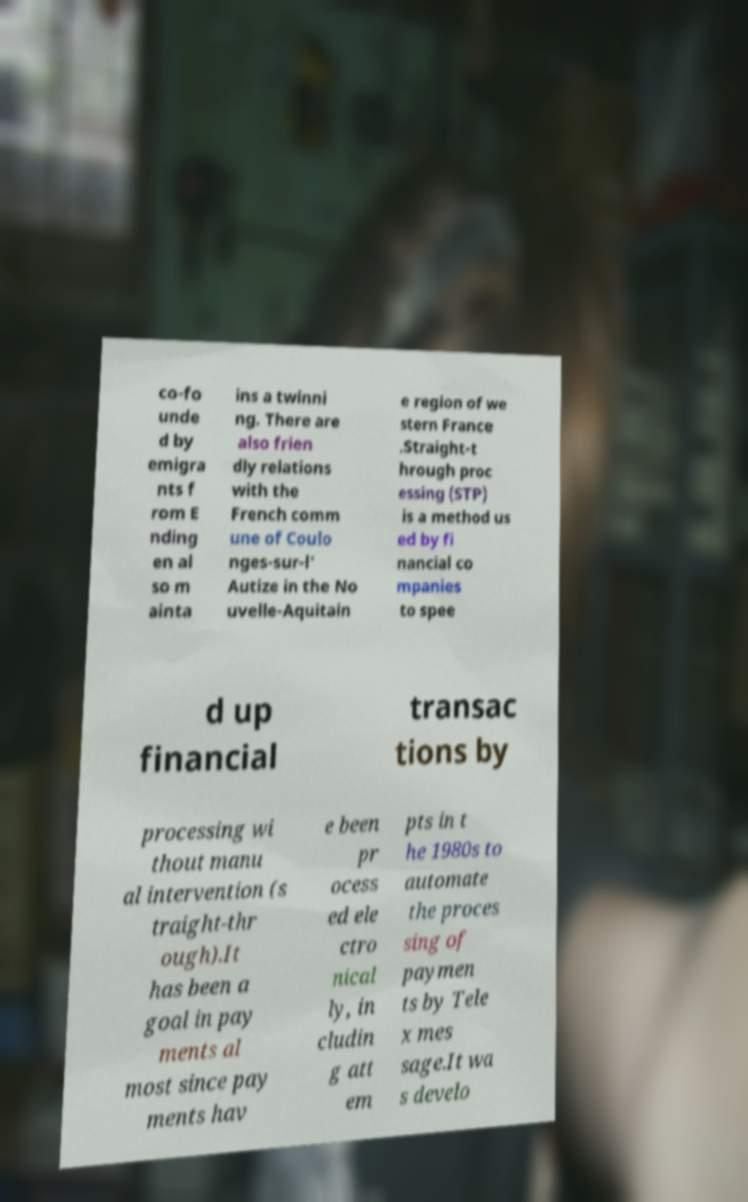I need the written content from this picture converted into text. Can you do that? co-fo unde d by emigra nts f rom E nding en al so m ainta ins a twinni ng. There are also frien dly relations with the French comm une of Coulo nges-sur-l' Autize in the No uvelle-Aquitain e region of we stern France .Straight-t hrough proc essing (STP) is a method us ed by fi nancial co mpanies to spee d up financial transac tions by processing wi thout manu al intervention (s traight-thr ough).It has been a goal in pay ments al most since pay ments hav e been pr ocess ed ele ctro nical ly, in cludin g att em pts in t he 1980s to automate the proces sing of paymen ts by Tele x mes sage.It wa s develo 